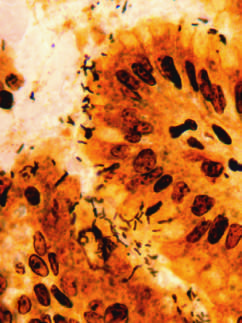what are highlighted in this warthin-starry silver stain?
Answer the question using a single word or phrase. Spiral-shaped helicobacter pylori bacilli 